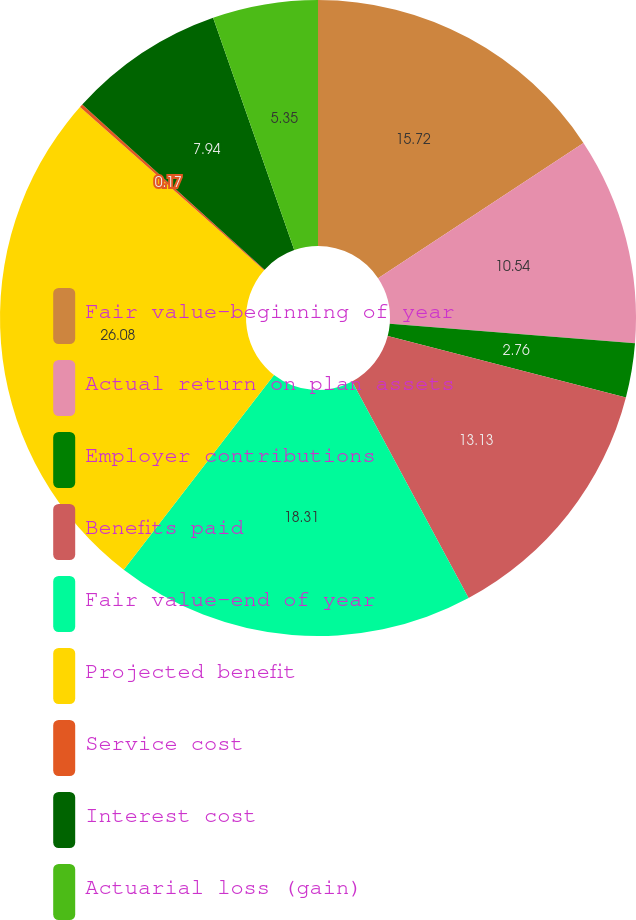Convert chart. <chart><loc_0><loc_0><loc_500><loc_500><pie_chart><fcel>Fair value-beginning of year<fcel>Actual return on plan assets<fcel>Employer contributions<fcel>Benefits paid<fcel>Fair value-end of year<fcel>Projected benefit<fcel>Service cost<fcel>Interest cost<fcel>Actuarial loss (gain)<nl><fcel>15.72%<fcel>10.54%<fcel>2.76%<fcel>13.13%<fcel>18.31%<fcel>26.08%<fcel>0.17%<fcel>7.94%<fcel>5.35%<nl></chart> 